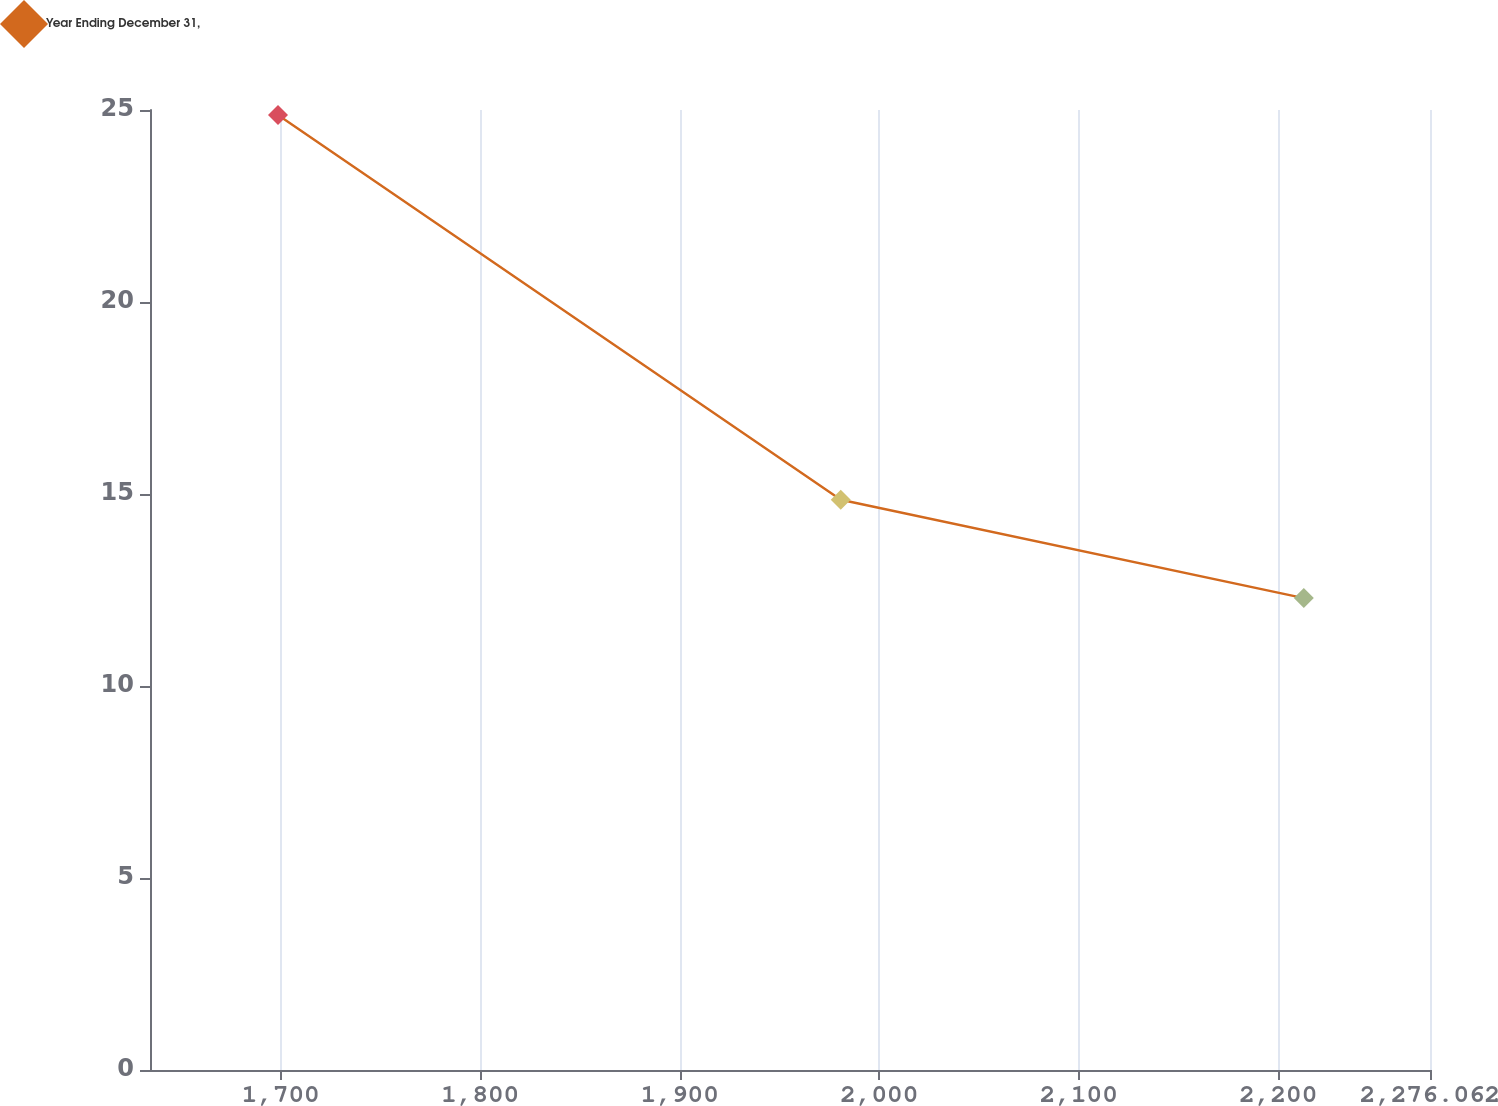Convert chart to OTSL. <chart><loc_0><loc_0><loc_500><loc_500><line_chart><ecel><fcel>Year Ending December 31,<nl><fcel>1698.64<fcel>24.87<nl><fcel>1980.72<fcel>14.85<nl><fcel>2212.8<fcel>12.29<nl><fcel>2276.51<fcel>9.24<nl><fcel>2340.22<fcel>7.5<nl></chart> 